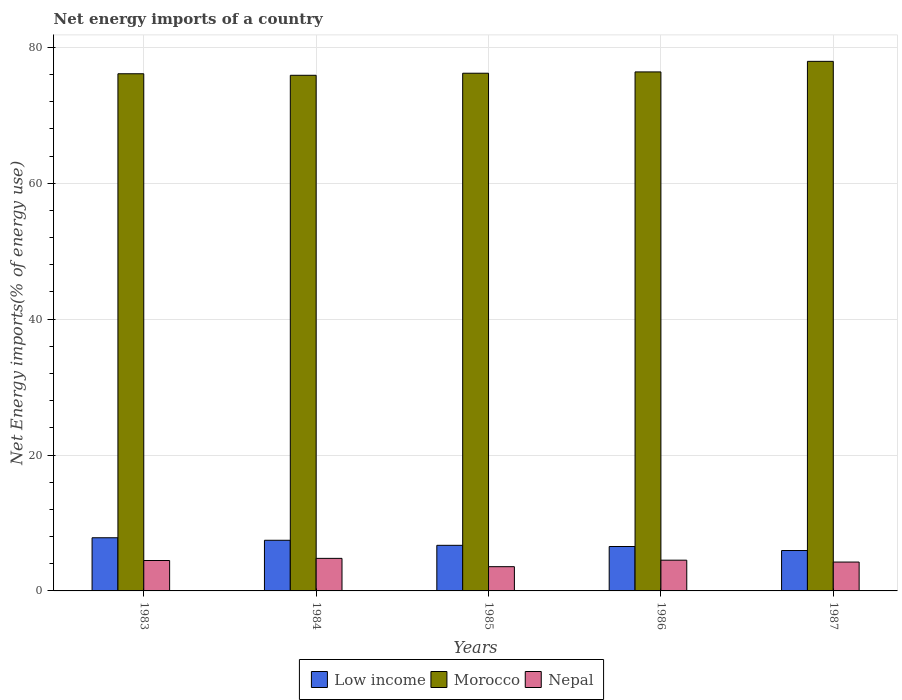How many groups of bars are there?
Provide a succinct answer. 5. How many bars are there on the 3rd tick from the left?
Provide a succinct answer. 3. How many bars are there on the 2nd tick from the right?
Offer a terse response. 3. What is the label of the 1st group of bars from the left?
Ensure brevity in your answer.  1983. In how many cases, is the number of bars for a given year not equal to the number of legend labels?
Provide a short and direct response. 0. What is the net energy imports in Nepal in 1983?
Your answer should be very brief. 4.48. Across all years, what is the maximum net energy imports in Nepal?
Offer a terse response. 4.79. Across all years, what is the minimum net energy imports in Morocco?
Provide a short and direct response. 75.89. In which year was the net energy imports in Nepal minimum?
Offer a terse response. 1985. What is the total net energy imports in Morocco in the graph?
Provide a succinct answer. 382.5. What is the difference between the net energy imports in Nepal in 1985 and that in 1986?
Your response must be concise. -0.96. What is the difference between the net energy imports in Morocco in 1986 and the net energy imports in Low income in 1985?
Offer a very short reply. 69.67. What is the average net energy imports in Nepal per year?
Keep it short and to the point. 4.32. In the year 1984, what is the difference between the net energy imports in Morocco and net energy imports in Nepal?
Your response must be concise. 71.09. What is the ratio of the net energy imports in Low income in 1984 to that in 1985?
Offer a terse response. 1.11. Is the net energy imports in Nepal in 1984 less than that in 1986?
Your response must be concise. No. Is the difference between the net energy imports in Morocco in 1984 and 1987 greater than the difference between the net energy imports in Nepal in 1984 and 1987?
Give a very brief answer. No. What is the difference between the highest and the second highest net energy imports in Nepal?
Your response must be concise. 0.27. What is the difference between the highest and the lowest net energy imports in Nepal?
Ensure brevity in your answer.  1.22. In how many years, is the net energy imports in Morocco greater than the average net energy imports in Morocco taken over all years?
Your answer should be compact. 1. What does the 2nd bar from the right in 1985 represents?
Ensure brevity in your answer.  Morocco. Are all the bars in the graph horizontal?
Give a very brief answer. No. How many years are there in the graph?
Offer a very short reply. 5. What is the difference between two consecutive major ticks on the Y-axis?
Provide a short and direct response. 20. Are the values on the major ticks of Y-axis written in scientific E-notation?
Provide a short and direct response. No. Does the graph contain any zero values?
Ensure brevity in your answer.  No. Where does the legend appear in the graph?
Give a very brief answer. Bottom center. How many legend labels are there?
Provide a succinct answer. 3. How are the legend labels stacked?
Your answer should be very brief. Horizontal. What is the title of the graph?
Give a very brief answer. Net energy imports of a country. Does "Azerbaijan" appear as one of the legend labels in the graph?
Provide a succinct answer. No. What is the label or title of the X-axis?
Your answer should be compact. Years. What is the label or title of the Y-axis?
Provide a succinct answer. Net Energy imports(% of energy use). What is the Net Energy imports(% of energy use) in Low income in 1983?
Provide a short and direct response. 7.82. What is the Net Energy imports(% of energy use) in Morocco in 1983?
Offer a terse response. 76.11. What is the Net Energy imports(% of energy use) of Nepal in 1983?
Give a very brief answer. 4.48. What is the Net Energy imports(% of energy use) of Low income in 1984?
Keep it short and to the point. 7.45. What is the Net Energy imports(% of energy use) of Morocco in 1984?
Offer a very short reply. 75.89. What is the Net Energy imports(% of energy use) in Nepal in 1984?
Keep it short and to the point. 4.79. What is the Net Energy imports(% of energy use) of Low income in 1985?
Provide a short and direct response. 6.71. What is the Net Energy imports(% of energy use) in Morocco in 1985?
Provide a succinct answer. 76.19. What is the Net Energy imports(% of energy use) of Nepal in 1985?
Make the answer very short. 3.57. What is the Net Energy imports(% of energy use) in Low income in 1986?
Make the answer very short. 6.54. What is the Net Energy imports(% of energy use) in Morocco in 1986?
Your response must be concise. 76.38. What is the Net Energy imports(% of energy use) of Nepal in 1986?
Make the answer very short. 4.52. What is the Net Energy imports(% of energy use) in Low income in 1987?
Make the answer very short. 5.94. What is the Net Energy imports(% of energy use) of Morocco in 1987?
Your answer should be compact. 77.94. What is the Net Energy imports(% of energy use) in Nepal in 1987?
Provide a succinct answer. 4.25. Across all years, what is the maximum Net Energy imports(% of energy use) in Low income?
Offer a very short reply. 7.82. Across all years, what is the maximum Net Energy imports(% of energy use) of Morocco?
Your answer should be compact. 77.94. Across all years, what is the maximum Net Energy imports(% of energy use) of Nepal?
Ensure brevity in your answer.  4.79. Across all years, what is the minimum Net Energy imports(% of energy use) of Low income?
Keep it short and to the point. 5.94. Across all years, what is the minimum Net Energy imports(% of energy use) of Morocco?
Your answer should be very brief. 75.89. Across all years, what is the minimum Net Energy imports(% of energy use) of Nepal?
Ensure brevity in your answer.  3.57. What is the total Net Energy imports(% of energy use) of Low income in the graph?
Give a very brief answer. 34.47. What is the total Net Energy imports(% of energy use) of Morocco in the graph?
Provide a short and direct response. 382.5. What is the total Net Energy imports(% of energy use) of Nepal in the graph?
Keep it short and to the point. 21.61. What is the difference between the Net Energy imports(% of energy use) in Low income in 1983 and that in 1984?
Ensure brevity in your answer.  0.37. What is the difference between the Net Energy imports(% of energy use) in Morocco in 1983 and that in 1984?
Keep it short and to the point. 0.22. What is the difference between the Net Energy imports(% of energy use) of Nepal in 1983 and that in 1984?
Keep it short and to the point. -0.32. What is the difference between the Net Energy imports(% of energy use) of Low income in 1983 and that in 1985?
Give a very brief answer. 1.11. What is the difference between the Net Energy imports(% of energy use) in Morocco in 1983 and that in 1985?
Keep it short and to the point. -0.08. What is the difference between the Net Energy imports(% of energy use) in Nepal in 1983 and that in 1985?
Give a very brief answer. 0.91. What is the difference between the Net Energy imports(% of energy use) of Low income in 1983 and that in 1986?
Your response must be concise. 1.29. What is the difference between the Net Energy imports(% of energy use) of Morocco in 1983 and that in 1986?
Offer a very short reply. -0.27. What is the difference between the Net Energy imports(% of energy use) of Nepal in 1983 and that in 1986?
Your answer should be very brief. -0.05. What is the difference between the Net Energy imports(% of energy use) of Low income in 1983 and that in 1987?
Keep it short and to the point. 1.88. What is the difference between the Net Energy imports(% of energy use) in Morocco in 1983 and that in 1987?
Your answer should be compact. -1.83. What is the difference between the Net Energy imports(% of energy use) of Nepal in 1983 and that in 1987?
Ensure brevity in your answer.  0.23. What is the difference between the Net Energy imports(% of energy use) of Low income in 1984 and that in 1985?
Give a very brief answer. 0.74. What is the difference between the Net Energy imports(% of energy use) in Morocco in 1984 and that in 1985?
Make the answer very short. -0.3. What is the difference between the Net Energy imports(% of energy use) of Nepal in 1984 and that in 1985?
Provide a succinct answer. 1.22. What is the difference between the Net Energy imports(% of energy use) of Low income in 1984 and that in 1986?
Make the answer very short. 0.92. What is the difference between the Net Energy imports(% of energy use) of Morocco in 1984 and that in 1986?
Keep it short and to the point. -0.5. What is the difference between the Net Energy imports(% of energy use) of Nepal in 1984 and that in 1986?
Make the answer very short. 0.27. What is the difference between the Net Energy imports(% of energy use) of Low income in 1984 and that in 1987?
Ensure brevity in your answer.  1.51. What is the difference between the Net Energy imports(% of energy use) in Morocco in 1984 and that in 1987?
Keep it short and to the point. -2.05. What is the difference between the Net Energy imports(% of energy use) of Nepal in 1984 and that in 1987?
Your answer should be compact. 0.54. What is the difference between the Net Energy imports(% of energy use) of Low income in 1985 and that in 1986?
Ensure brevity in your answer.  0.17. What is the difference between the Net Energy imports(% of energy use) in Morocco in 1985 and that in 1986?
Give a very brief answer. -0.19. What is the difference between the Net Energy imports(% of energy use) of Nepal in 1985 and that in 1986?
Provide a succinct answer. -0.96. What is the difference between the Net Energy imports(% of energy use) in Low income in 1985 and that in 1987?
Provide a succinct answer. 0.77. What is the difference between the Net Energy imports(% of energy use) of Morocco in 1985 and that in 1987?
Offer a terse response. -1.75. What is the difference between the Net Energy imports(% of energy use) of Nepal in 1985 and that in 1987?
Your response must be concise. -0.68. What is the difference between the Net Energy imports(% of energy use) in Low income in 1986 and that in 1987?
Ensure brevity in your answer.  0.59. What is the difference between the Net Energy imports(% of energy use) in Morocco in 1986 and that in 1987?
Your response must be concise. -1.55. What is the difference between the Net Energy imports(% of energy use) of Nepal in 1986 and that in 1987?
Keep it short and to the point. 0.28. What is the difference between the Net Energy imports(% of energy use) in Low income in 1983 and the Net Energy imports(% of energy use) in Morocco in 1984?
Make the answer very short. -68.06. What is the difference between the Net Energy imports(% of energy use) in Low income in 1983 and the Net Energy imports(% of energy use) in Nepal in 1984?
Make the answer very short. 3.03. What is the difference between the Net Energy imports(% of energy use) of Morocco in 1983 and the Net Energy imports(% of energy use) of Nepal in 1984?
Your answer should be compact. 71.32. What is the difference between the Net Energy imports(% of energy use) of Low income in 1983 and the Net Energy imports(% of energy use) of Morocco in 1985?
Ensure brevity in your answer.  -68.37. What is the difference between the Net Energy imports(% of energy use) of Low income in 1983 and the Net Energy imports(% of energy use) of Nepal in 1985?
Offer a terse response. 4.26. What is the difference between the Net Energy imports(% of energy use) of Morocco in 1983 and the Net Energy imports(% of energy use) of Nepal in 1985?
Give a very brief answer. 72.54. What is the difference between the Net Energy imports(% of energy use) in Low income in 1983 and the Net Energy imports(% of energy use) in Morocco in 1986?
Ensure brevity in your answer.  -68.56. What is the difference between the Net Energy imports(% of energy use) of Low income in 1983 and the Net Energy imports(% of energy use) of Nepal in 1986?
Offer a very short reply. 3.3. What is the difference between the Net Energy imports(% of energy use) in Morocco in 1983 and the Net Energy imports(% of energy use) in Nepal in 1986?
Provide a succinct answer. 71.59. What is the difference between the Net Energy imports(% of energy use) of Low income in 1983 and the Net Energy imports(% of energy use) of Morocco in 1987?
Keep it short and to the point. -70.11. What is the difference between the Net Energy imports(% of energy use) of Low income in 1983 and the Net Energy imports(% of energy use) of Nepal in 1987?
Offer a very short reply. 3.57. What is the difference between the Net Energy imports(% of energy use) in Morocco in 1983 and the Net Energy imports(% of energy use) in Nepal in 1987?
Make the answer very short. 71.86. What is the difference between the Net Energy imports(% of energy use) of Low income in 1984 and the Net Energy imports(% of energy use) of Morocco in 1985?
Give a very brief answer. -68.73. What is the difference between the Net Energy imports(% of energy use) of Low income in 1984 and the Net Energy imports(% of energy use) of Nepal in 1985?
Offer a terse response. 3.89. What is the difference between the Net Energy imports(% of energy use) in Morocco in 1984 and the Net Energy imports(% of energy use) in Nepal in 1985?
Provide a succinct answer. 72.32. What is the difference between the Net Energy imports(% of energy use) of Low income in 1984 and the Net Energy imports(% of energy use) of Morocco in 1986?
Your answer should be very brief. -68.93. What is the difference between the Net Energy imports(% of energy use) of Low income in 1984 and the Net Energy imports(% of energy use) of Nepal in 1986?
Provide a short and direct response. 2.93. What is the difference between the Net Energy imports(% of energy use) of Morocco in 1984 and the Net Energy imports(% of energy use) of Nepal in 1986?
Give a very brief answer. 71.36. What is the difference between the Net Energy imports(% of energy use) of Low income in 1984 and the Net Energy imports(% of energy use) of Morocco in 1987?
Provide a succinct answer. -70.48. What is the difference between the Net Energy imports(% of energy use) of Low income in 1984 and the Net Energy imports(% of energy use) of Nepal in 1987?
Keep it short and to the point. 3.21. What is the difference between the Net Energy imports(% of energy use) in Morocco in 1984 and the Net Energy imports(% of energy use) in Nepal in 1987?
Provide a short and direct response. 71.64. What is the difference between the Net Energy imports(% of energy use) in Low income in 1985 and the Net Energy imports(% of energy use) in Morocco in 1986?
Your response must be concise. -69.67. What is the difference between the Net Energy imports(% of energy use) of Low income in 1985 and the Net Energy imports(% of energy use) of Nepal in 1986?
Keep it short and to the point. 2.19. What is the difference between the Net Energy imports(% of energy use) in Morocco in 1985 and the Net Energy imports(% of energy use) in Nepal in 1986?
Make the answer very short. 71.66. What is the difference between the Net Energy imports(% of energy use) in Low income in 1985 and the Net Energy imports(% of energy use) in Morocco in 1987?
Give a very brief answer. -71.22. What is the difference between the Net Energy imports(% of energy use) in Low income in 1985 and the Net Energy imports(% of energy use) in Nepal in 1987?
Keep it short and to the point. 2.46. What is the difference between the Net Energy imports(% of energy use) in Morocco in 1985 and the Net Energy imports(% of energy use) in Nepal in 1987?
Offer a terse response. 71.94. What is the difference between the Net Energy imports(% of energy use) in Low income in 1986 and the Net Energy imports(% of energy use) in Morocco in 1987?
Provide a short and direct response. -71.4. What is the difference between the Net Energy imports(% of energy use) of Low income in 1986 and the Net Energy imports(% of energy use) of Nepal in 1987?
Provide a succinct answer. 2.29. What is the difference between the Net Energy imports(% of energy use) of Morocco in 1986 and the Net Energy imports(% of energy use) of Nepal in 1987?
Ensure brevity in your answer.  72.13. What is the average Net Energy imports(% of energy use) of Low income per year?
Your answer should be very brief. 6.89. What is the average Net Energy imports(% of energy use) of Morocco per year?
Your response must be concise. 76.5. What is the average Net Energy imports(% of energy use) of Nepal per year?
Your answer should be very brief. 4.32. In the year 1983, what is the difference between the Net Energy imports(% of energy use) of Low income and Net Energy imports(% of energy use) of Morocco?
Ensure brevity in your answer.  -68.29. In the year 1983, what is the difference between the Net Energy imports(% of energy use) in Low income and Net Energy imports(% of energy use) in Nepal?
Provide a short and direct response. 3.35. In the year 1983, what is the difference between the Net Energy imports(% of energy use) of Morocco and Net Energy imports(% of energy use) of Nepal?
Your answer should be very brief. 71.63. In the year 1984, what is the difference between the Net Energy imports(% of energy use) in Low income and Net Energy imports(% of energy use) in Morocco?
Your answer should be very brief. -68.43. In the year 1984, what is the difference between the Net Energy imports(% of energy use) of Low income and Net Energy imports(% of energy use) of Nepal?
Ensure brevity in your answer.  2.66. In the year 1984, what is the difference between the Net Energy imports(% of energy use) in Morocco and Net Energy imports(% of energy use) in Nepal?
Provide a short and direct response. 71.09. In the year 1985, what is the difference between the Net Energy imports(% of energy use) of Low income and Net Energy imports(% of energy use) of Morocco?
Provide a succinct answer. -69.48. In the year 1985, what is the difference between the Net Energy imports(% of energy use) in Low income and Net Energy imports(% of energy use) in Nepal?
Ensure brevity in your answer.  3.14. In the year 1985, what is the difference between the Net Energy imports(% of energy use) in Morocco and Net Energy imports(% of energy use) in Nepal?
Ensure brevity in your answer.  72.62. In the year 1986, what is the difference between the Net Energy imports(% of energy use) in Low income and Net Energy imports(% of energy use) in Morocco?
Ensure brevity in your answer.  -69.84. In the year 1986, what is the difference between the Net Energy imports(% of energy use) of Low income and Net Energy imports(% of energy use) of Nepal?
Make the answer very short. 2.01. In the year 1986, what is the difference between the Net Energy imports(% of energy use) of Morocco and Net Energy imports(% of energy use) of Nepal?
Your answer should be very brief. 71.86. In the year 1987, what is the difference between the Net Energy imports(% of energy use) of Low income and Net Energy imports(% of energy use) of Morocco?
Make the answer very short. -71.99. In the year 1987, what is the difference between the Net Energy imports(% of energy use) in Low income and Net Energy imports(% of energy use) in Nepal?
Ensure brevity in your answer.  1.7. In the year 1987, what is the difference between the Net Energy imports(% of energy use) in Morocco and Net Energy imports(% of energy use) in Nepal?
Provide a succinct answer. 73.69. What is the ratio of the Net Energy imports(% of energy use) in Low income in 1983 to that in 1984?
Offer a very short reply. 1.05. What is the ratio of the Net Energy imports(% of energy use) in Nepal in 1983 to that in 1984?
Provide a short and direct response. 0.93. What is the ratio of the Net Energy imports(% of energy use) of Low income in 1983 to that in 1985?
Offer a very short reply. 1.17. What is the ratio of the Net Energy imports(% of energy use) of Morocco in 1983 to that in 1985?
Offer a terse response. 1. What is the ratio of the Net Energy imports(% of energy use) in Nepal in 1983 to that in 1985?
Provide a short and direct response. 1.25. What is the ratio of the Net Energy imports(% of energy use) in Low income in 1983 to that in 1986?
Offer a very short reply. 1.2. What is the ratio of the Net Energy imports(% of energy use) in Low income in 1983 to that in 1987?
Your response must be concise. 1.32. What is the ratio of the Net Energy imports(% of energy use) of Morocco in 1983 to that in 1987?
Your answer should be compact. 0.98. What is the ratio of the Net Energy imports(% of energy use) of Nepal in 1983 to that in 1987?
Keep it short and to the point. 1.05. What is the ratio of the Net Energy imports(% of energy use) in Low income in 1984 to that in 1985?
Your answer should be very brief. 1.11. What is the ratio of the Net Energy imports(% of energy use) in Morocco in 1984 to that in 1985?
Keep it short and to the point. 1. What is the ratio of the Net Energy imports(% of energy use) in Nepal in 1984 to that in 1985?
Your answer should be compact. 1.34. What is the ratio of the Net Energy imports(% of energy use) of Low income in 1984 to that in 1986?
Make the answer very short. 1.14. What is the ratio of the Net Energy imports(% of energy use) of Nepal in 1984 to that in 1986?
Offer a terse response. 1.06. What is the ratio of the Net Energy imports(% of energy use) in Low income in 1984 to that in 1987?
Your answer should be very brief. 1.25. What is the ratio of the Net Energy imports(% of energy use) of Morocco in 1984 to that in 1987?
Provide a succinct answer. 0.97. What is the ratio of the Net Energy imports(% of energy use) in Nepal in 1984 to that in 1987?
Offer a very short reply. 1.13. What is the ratio of the Net Energy imports(% of energy use) of Low income in 1985 to that in 1986?
Offer a terse response. 1.03. What is the ratio of the Net Energy imports(% of energy use) of Morocco in 1985 to that in 1986?
Keep it short and to the point. 1. What is the ratio of the Net Energy imports(% of energy use) in Nepal in 1985 to that in 1986?
Your answer should be compact. 0.79. What is the ratio of the Net Energy imports(% of energy use) in Low income in 1985 to that in 1987?
Make the answer very short. 1.13. What is the ratio of the Net Energy imports(% of energy use) of Morocco in 1985 to that in 1987?
Make the answer very short. 0.98. What is the ratio of the Net Energy imports(% of energy use) of Nepal in 1985 to that in 1987?
Your response must be concise. 0.84. What is the ratio of the Net Energy imports(% of energy use) of Low income in 1986 to that in 1987?
Give a very brief answer. 1.1. What is the ratio of the Net Energy imports(% of energy use) of Morocco in 1986 to that in 1987?
Provide a short and direct response. 0.98. What is the ratio of the Net Energy imports(% of energy use) of Nepal in 1986 to that in 1987?
Give a very brief answer. 1.06. What is the difference between the highest and the second highest Net Energy imports(% of energy use) in Low income?
Offer a very short reply. 0.37. What is the difference between the highest and the second highest Net Energy imports(% of energy use) of Morocco?
Give a very brief answer. 1.55. What is the difference between the highest and the second highest Net Energy imports(% of energy use) of Nepal?
Your answer should be very brief. 0.27. What is the difference between the highest and the lowest Net Energy imports(% of energy use) of Low income?
Keep it short and to the point. 1.88. What is the difference between the highest and the lowest Net Energy imports(% of energy use) in Morocco?
Offer a terse response. 2.05. What is the difference between the highest and the lowest Net Energy imports(% of energy use) of Nepal?
Make the answer very short. 1.22. 